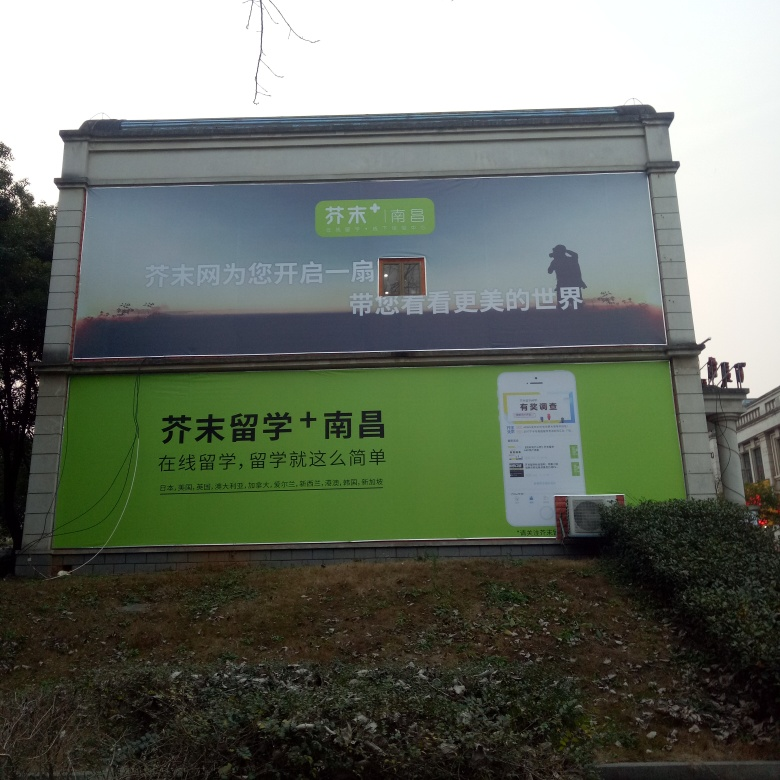What can you tell me about the content on the billboard? The billboard appears to be an advertisement, with two distinct sections. The top section displays a silhouette of a person in a rural setting, which might suggest a service or product related to agriculture or outdoor work. Below, there's text and an image of a mobile device, likely indicating a mobile app or digital service. Unfortunately, I cannot provide a translation of the text. 